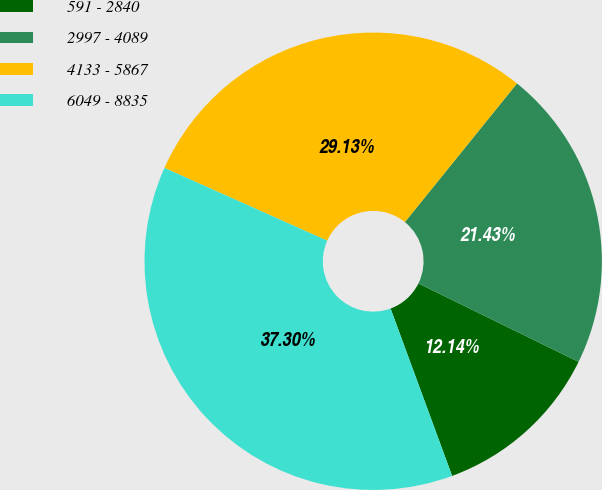<chart> <loc_0><loc_0><loc_500><loc_500><pie_chart><fcel>591 - 2840<fcel>2997 - 4089<fcel>4133 - 5867<fcel>6049 - 8835<nl><fcel>12.14%<fcel>21.43%<fcel>29.13%<fcel>37.3%<nl></chart> 